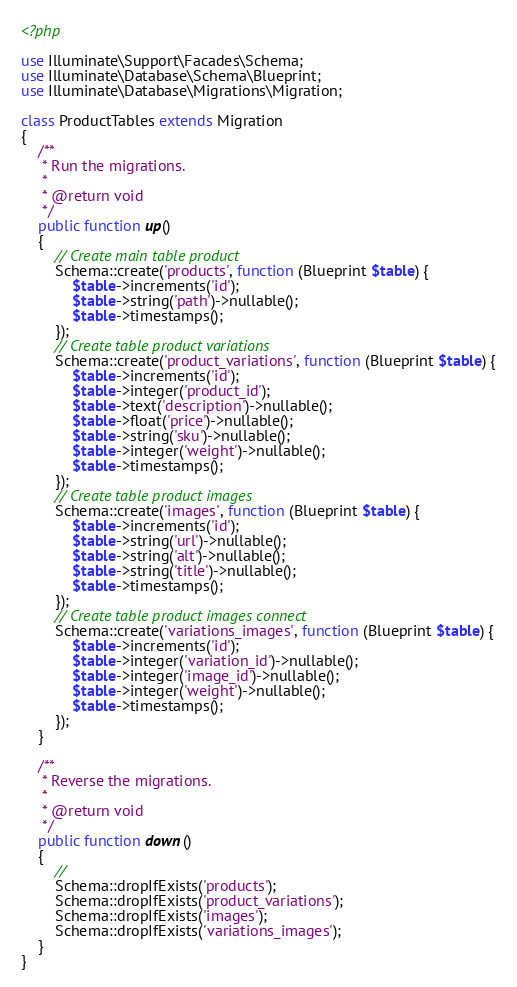Convert code to text. <code><loc_0><loc_0><loc_500><loc_500><_PHP_><?php

use Illuminate\Support\Facades\Schema;
use Illuminate\Database\Schema\Blueprint;
use Illuminate\Database\Migrations\Migration;

class ProductTables extends Migration
{
    /**
     * Run the migrations.
     *
     * @return void
     */
    public function up()
    {
        // Create main table product
        Schema::create('products', function (Blueprint $table) {
            $table->increments('id');
            $table->string('path')->nullable();
            $table->timestamps();
        });
        // Create table product variations
        Schema::create('product_variations', function (Blueprint $table) {
            $table->increments('id');
            $table->integer('product_id');
            $table->text('description')->nullable();
            $table->float('price')->nullable();
            $table->string('sku')->nullable();
            $table->integer('weight')->nullable();
            $table->timestamps();
        });
        // Create table product images
        Schema::create('images', function (Blueprint $table) {
            $table->increments('id');
            $table->string('url')->nullable();
            $table->string('alt')->nullable();
            $table->string('title')->nullable();
            $table->timestamps();
        });
        // Create table product images connect
        Schema::create('variations_images', function (Blueprint $table) {
            $table->increments('id');
            $table->integer('variation_id')->nullable();
            $table->integer('image_id')->nullable();
            $table->integer('weight')->nullable();
            $table->timestamps();
        });
    }

    /**
     * Reverse the migrations.
     *
     * @return void
     */
    public function down()
    {
        //
        Schema::dropIfExists('products');
        Schema::dropIfExists('product_variations');
        Schema::dropIfExists('images');
        Schema::dropIfExists('variations_images');
    }
}
</code> 